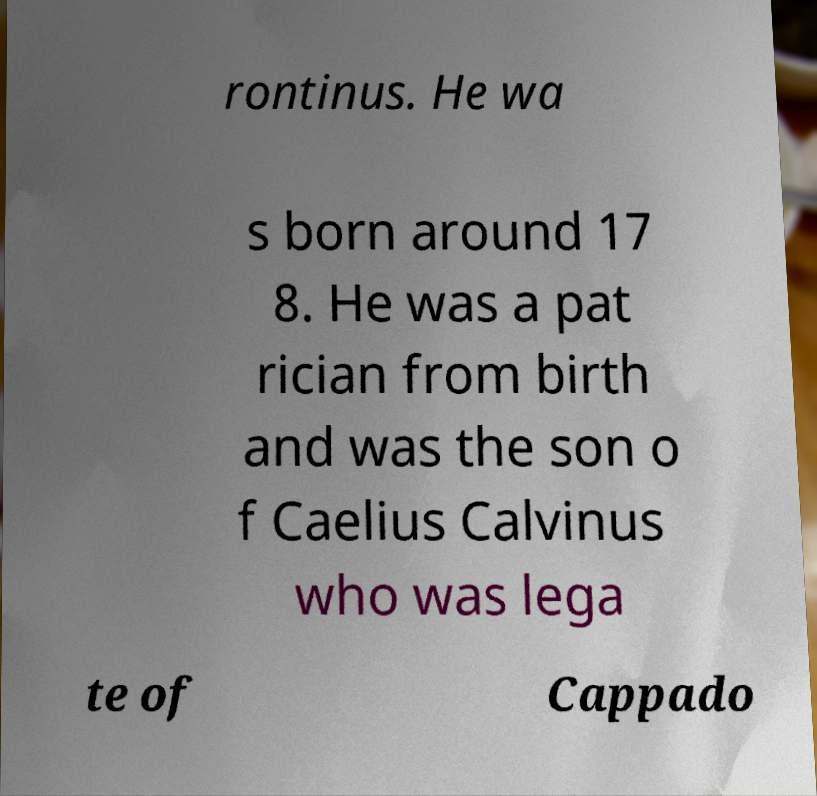For documentation purposes, I need the text within this image transcribed. Could you provide that? rontinus. He wa s born around 17 8. He was a pat rician from birth and was the son o f Caelius Calvinus who was lega te of Cappado 